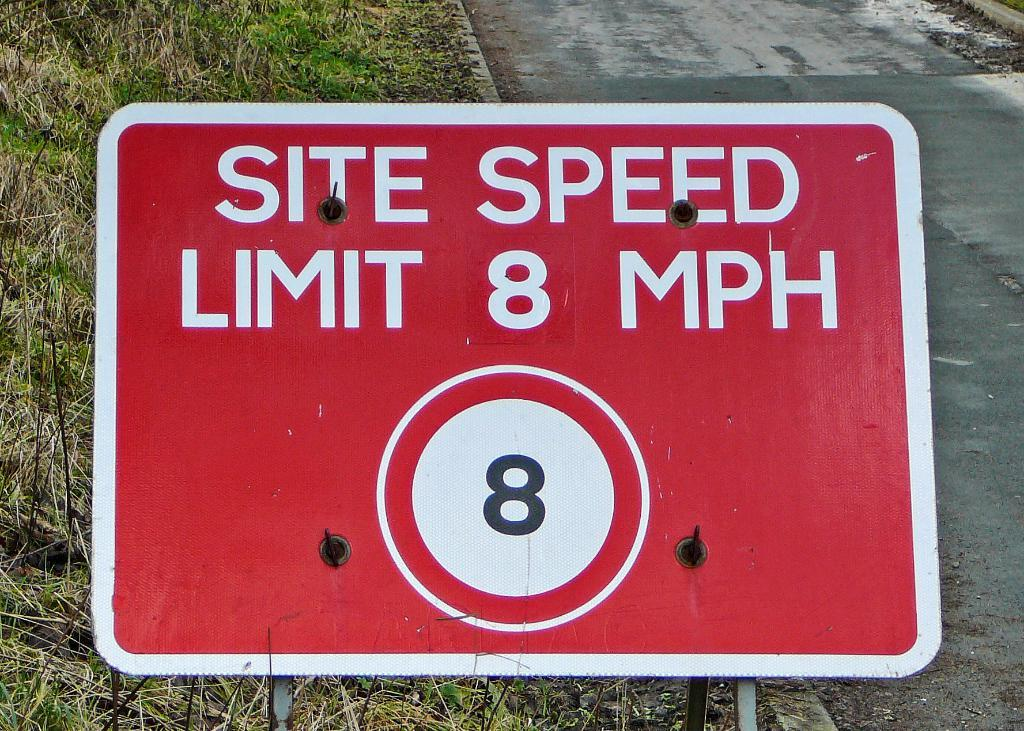<image>
Describe the image concisely. A red rectangular sign announces an 8 mile per hour site speed limit. 